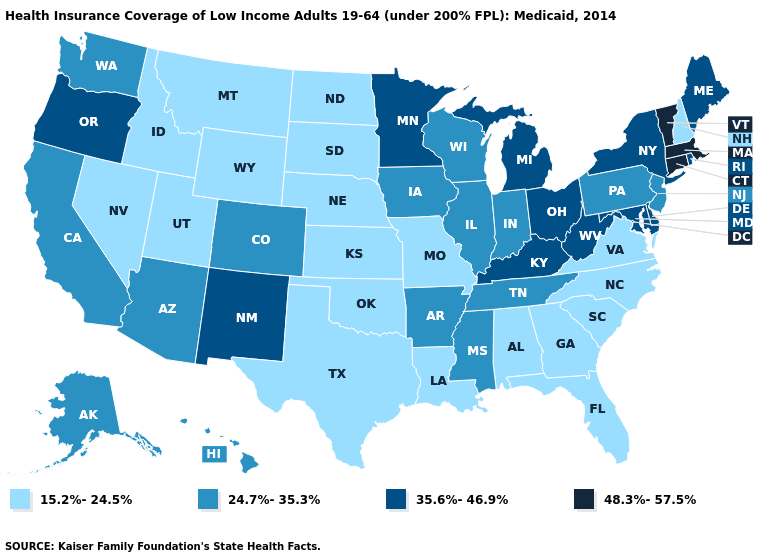How many symbols are there in the legend?
Short answer required. 4. Which states have the lowest value in the USA?
Short answer required. Alabama, Florida, Georgia, Idaho, Kansas, Louisiana, Missouri, Montana, Nebraska, Nevada, New Hampshire, North Carolina, North Dakota, Oklahoma, South Carolina, South Dakota, Texas, Utah, Virginia, Wyoming. Does Texas have the same value as Oregon?
Write a very short answer. No. What is the highest value in states that border Oregon?
Give a very brief answer. 24.7%-35.3%. Name the states that have a value in the range 48.3%-57.5%?
Short answer required. Connecticut, Massachusetts, Vermont. What is the value of Arizona?
Quick response, please. 24.7%-35.3%. Name the states that have a value in the range 24.7%-35.3%?
Quick response, please. Alaska, Arizona, Arkansas, California, Colorado, Hawaii, Illinois, Indiana, Iowa, Mississippi, New Jersey, Pennsylvania, Tennessee, Washington, Wisconsin. Does Vermont have the highest value in the USA?
Write a very short answer. Yes. What is the value of Michigan?
Give a very brief answer. 35.6%-46.9%. Among the states that border Rhode Island , which have the highest value?
Keep it brief. Connecticut, Massachusetts. What is the highest value in states that border Oklahoma?
Quick response, please. 35.6%-46.9%. Does Tennessee have the same value as Oklahoma?
Be succinct. No. What is the highest value in the West ?
Short answer required. 35.6%-46.9%. What is the value of South Dakota?
Be succinct. 15.2%-24.5%. What is the lowest value in the USA?
Quick response, please. 15.2%-24.5%. 